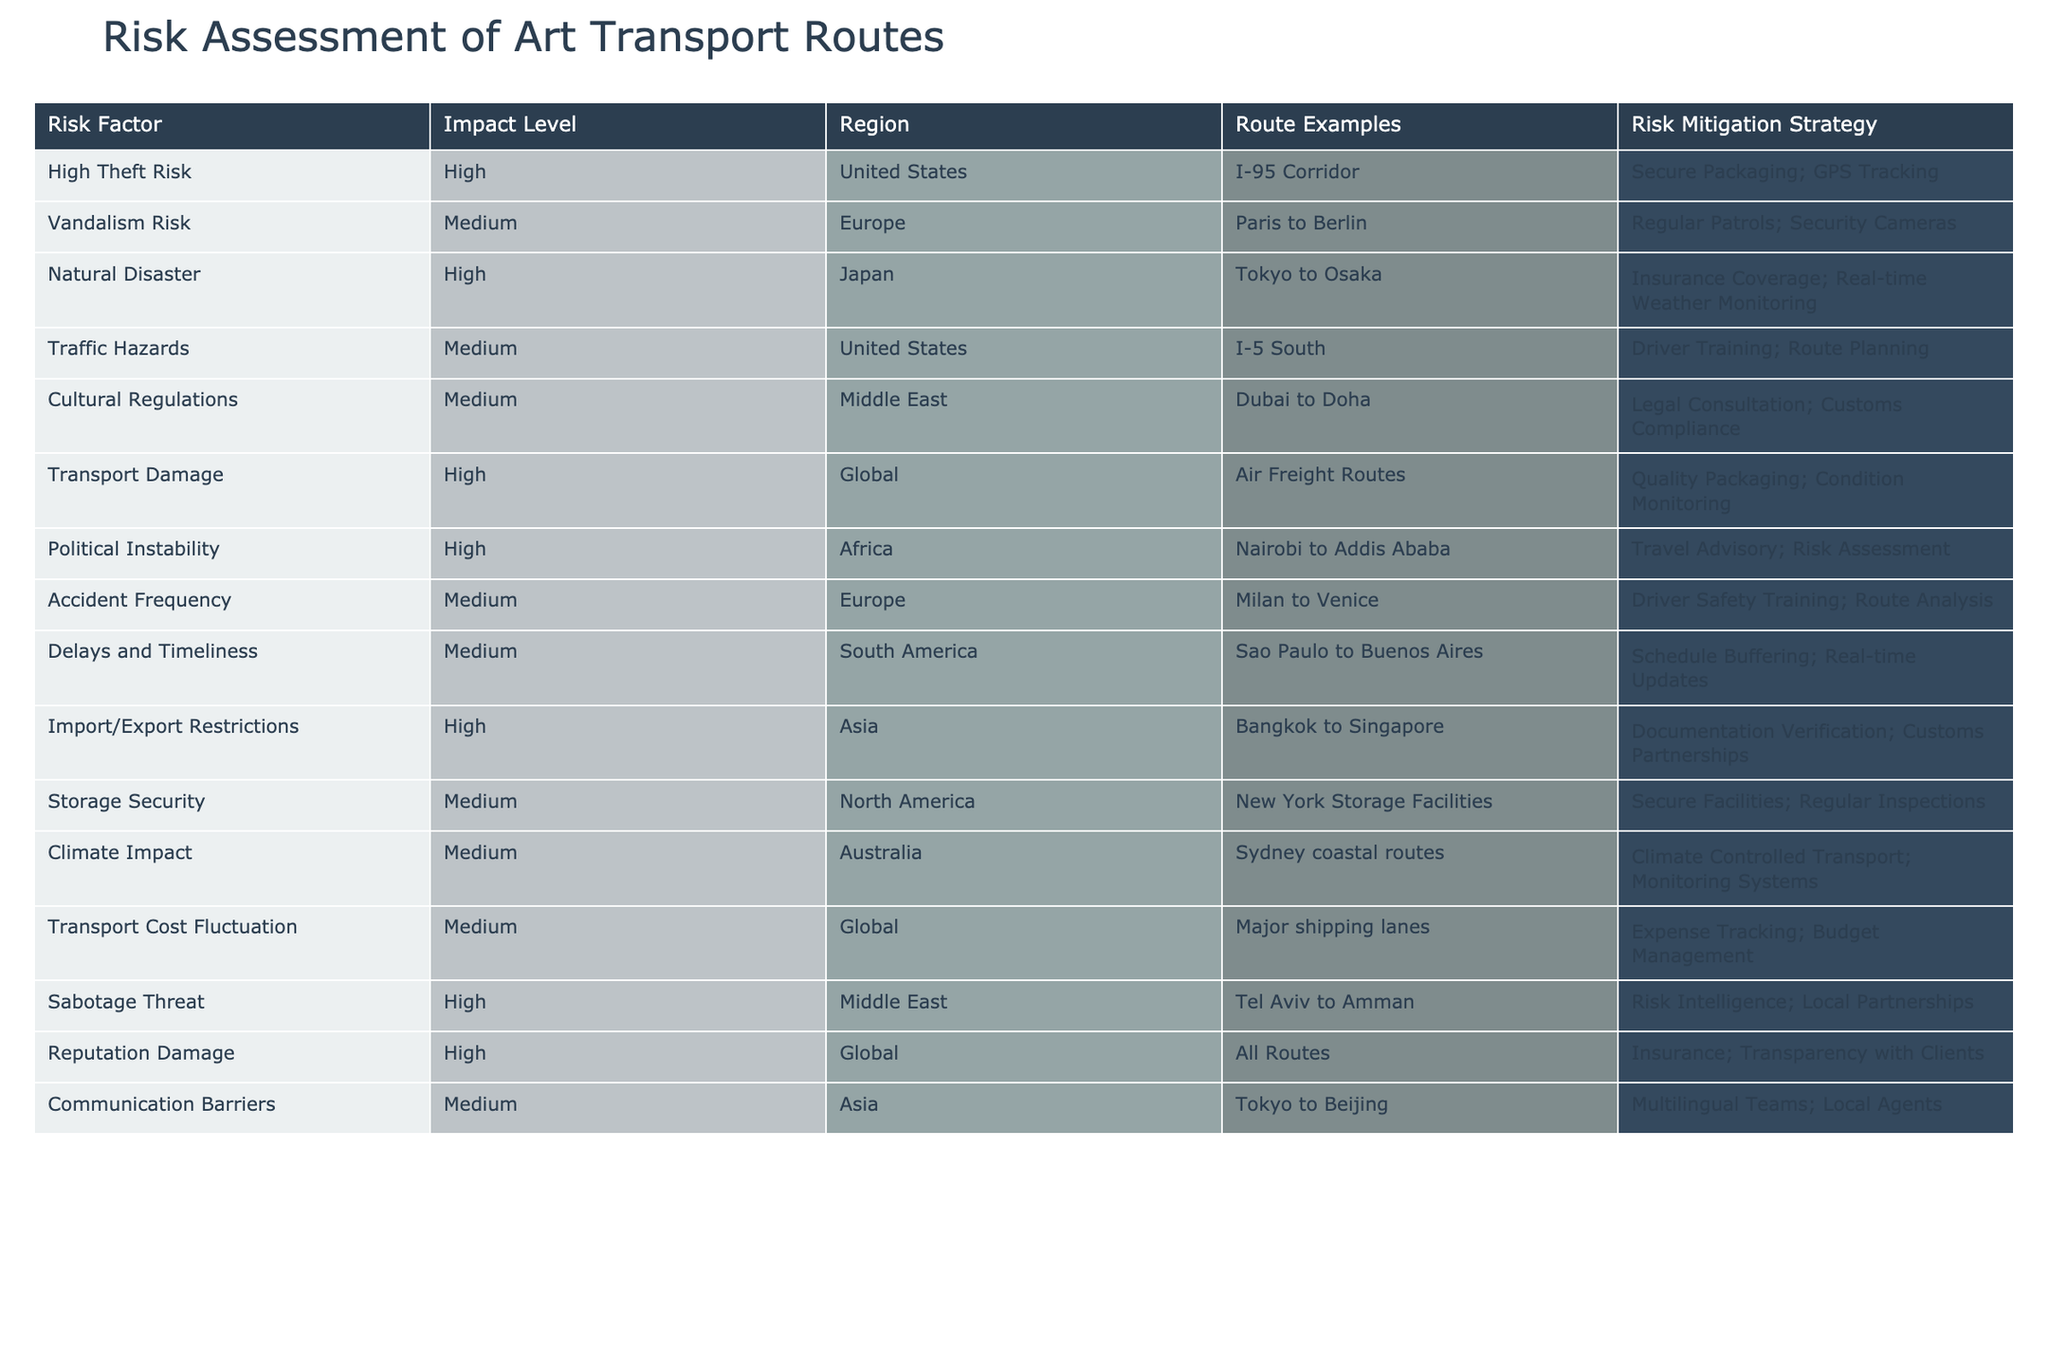What is the risk mitigation strategy for high theft risk in the United States? The table lists "Secure Packaging; GPS Tracking" under the risk mitigation strategy for high theft risk in the United States specifically relating to the I-95 Corridor.
Answer: Secure Packaging; GPS Tracking Which route has a medium level of vandalism risk in Europe? According to the table, the route identified with medium vandalism risk in Europe is from Paris to Berlin.
Answer: Paris to Berlin Is there an identified transport damage risk in any region? The table indicates that transport damage poses a high risk globally, specifically for air freight routes. Thus, there is indeed an identified transport damage risk.
Answer: Yes What strategies are recommended for mitigating delays and timeliness risks in South America? The table indicates that the recommended strategies for mitigating delays and timeliness risks on the Sao Paulo to Buenos Aires route are Schedule Buffering and Real-time Updates.
Answer: Schedule Buffering; Real-time Updates How many high risk categories are identified in the table? By reviewing the table, we can see that there are six high risk categories listed: High Theft Risk, Natural Disaster, Transport Damage, Political Instability, Import/Export Restrictions, and Sabotage Threat. Summing these gives a total of six categories.
Answer: 6 Which route example from Asia is mentioned under import/export restrictions? The table highlights Bangkok to Singapore as the route example for the high risk of import/export restrictions in Asia.
Answer: Bangkok to Singapore Are there any transport routes where the level of risk is not high? Yes, examining the table, several transport routes have risk levels medium or low, including the various routes in Europe and South America, such as Milan to Venice and Sao Paulo to Buenos Aires.
Answer: Yes What is the common risk mitigation strategy for both climate impact in Australia and communication barriers in Asia? The table does not specify a common strategy as they address different risks; climate impact mitigation involves Climate Controlled Transport and Monitoring Systems, while communication barriers utilize Multilingual Teams and Local Agents. Thus, there is no commonality.
Answer: No What is the total number of medium risk factors across all regions in the table? In the table, the identified medium risk factors are Vandalism Risk, Traffic Hazards, Cultural Regulations, Accident Frequency, Delays and Timeliness, Storage Security, Climate Impact, and Communication Barriers. There are a total of eight medium risk factors.
Answer: 8 